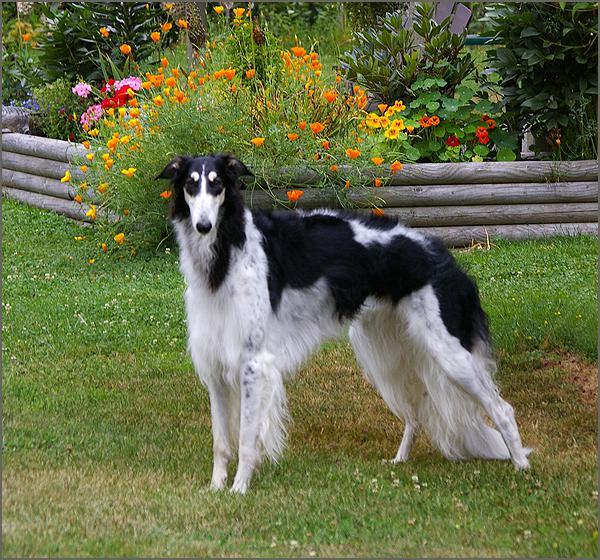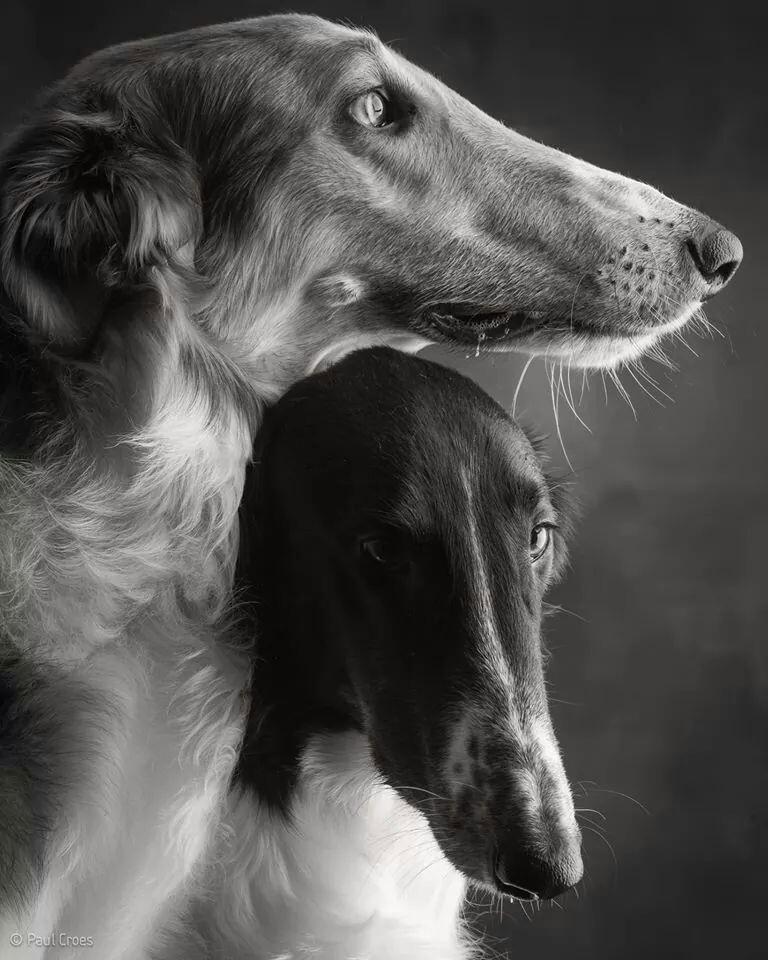The first image is the image on the left, the second image is the image on the right. For the images displayed, is the sentence "the left and right image contains the same number of dogs." factually correct? Answer yes or no. No. The first image is the image on the left, the second image is the image on the right. Evaluate the accuracy of this statement regarding the images: "Each image contains exactly one hound, and the dogs in the left and right images share similar fur coloring and body poses.". Is it true? Answer yes or no. No. 